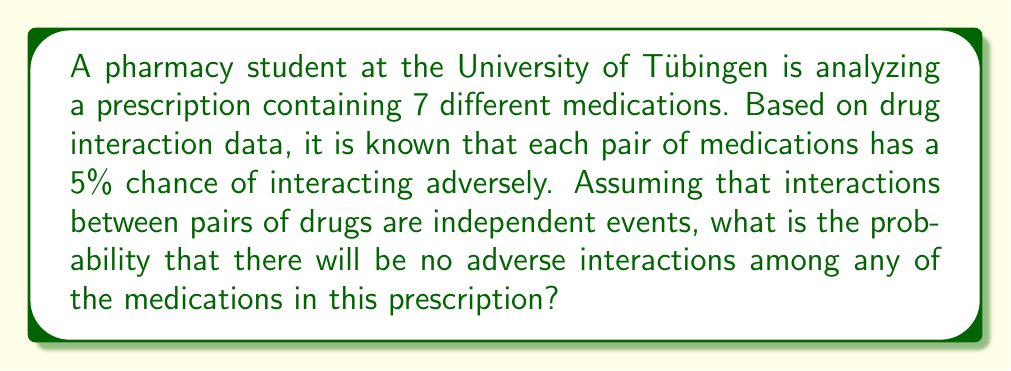Can you solve this math problem? To solve this problem, we need to follow these steps:

1) First, we need to calculate the total number of possible drug pairs in the prescription. This can be done using the combination formula:

   $$\binom{7}{2} = \frac{7!}{2!(7-2)!} = \frac{7 \cdot 6}{2} = 21$$

2) For each pair, the probability of no adverse interaction is 95% (or 0.95), as the probability of an adverse interaction is given as 5% (or 0.05).

3) For there to be no adverse interactions at all, each of the 21 pairs must not interact. Since these events are independent, we multiply the probabilities:

   $$(0.95)^{21}$$

4) Calculate this value:

   $$(0.95)^{21} \approx 0.3387$$

5) Therefore, the probability of no adverse interactions is approximately 0.3387 or 33.87%.

Note: In a real-world scenario, drug interactions are often more complex and not always independent. This problem is a simplified model for educational purposes.
Answer: The probability that there will be no adverse interactions among any of the medications in this prescription is approximately 0.3387 or 33.87%. 